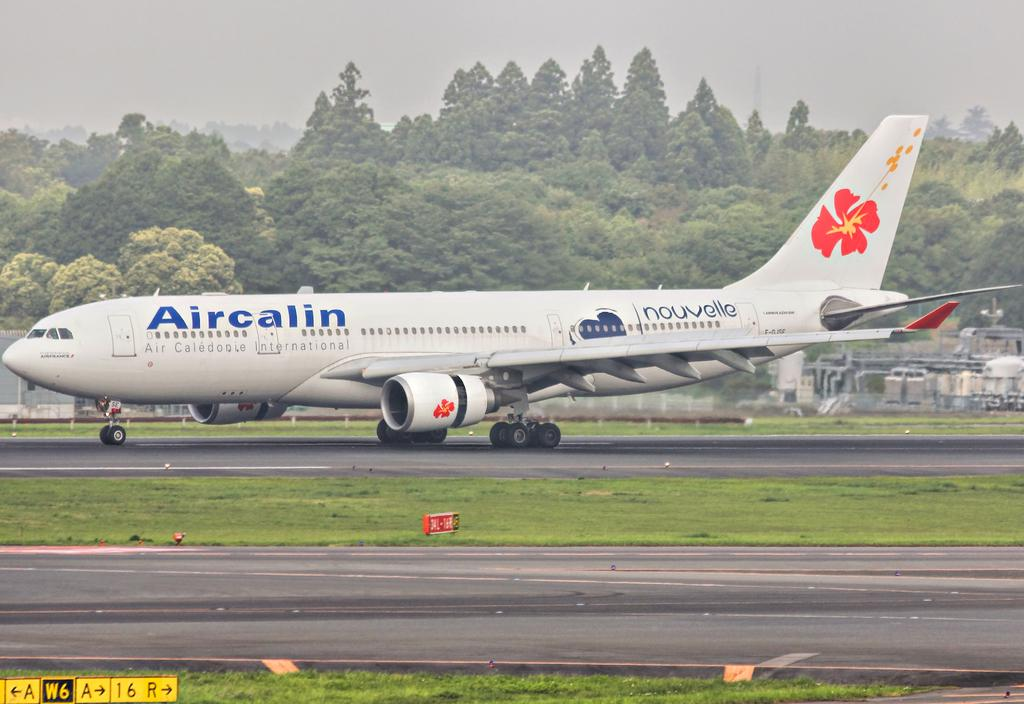Provide a one-sentence caption for the provided image. an airplane on a runway, branded with a aircalin decal. 